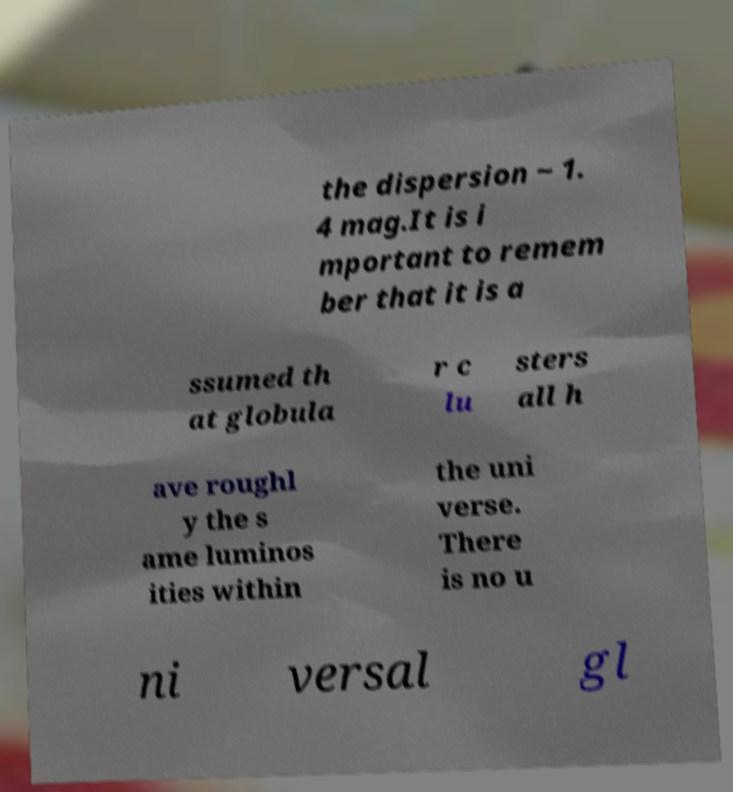Please identify and transcribe the text found in this image. the dispersion ~ 1. 4 mag.It is i mportant to remem ber that it is a ssumed th at globula r c lu sters all h ave roughl y the s ame luminos ities within the uni verse. There is no u ni versal gl 